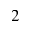<formula> <loc_0><loc_0><loc_500><loc_500>2</formula> 